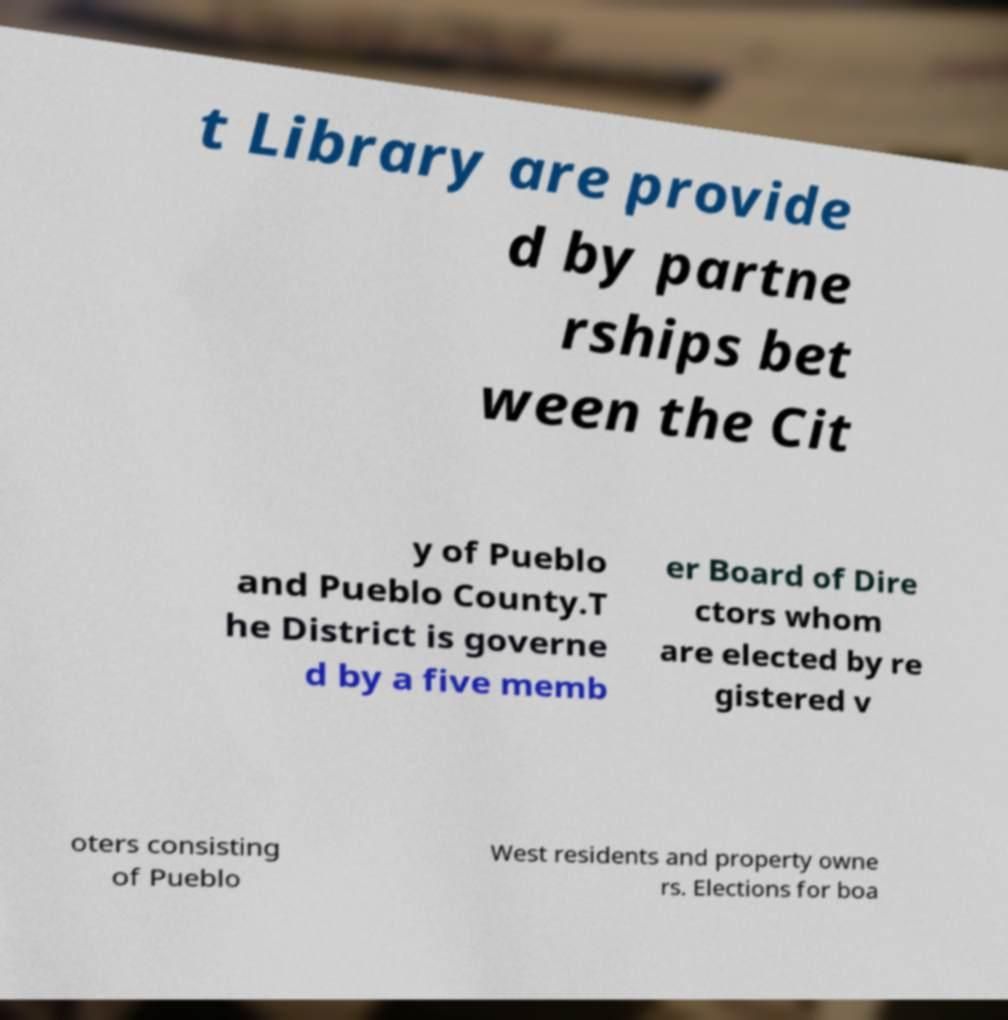I need the written content from this picture converted into text. Can you do that? t Library are provide d by partne rships bet ween the Cit y of Pueblo and Pueblo County.T he District is governe d by a five memb er Board of Dire ctors whom are elected by re gistered v oters consisting of Pueblo West residents and property owne rs. Elections for boa 